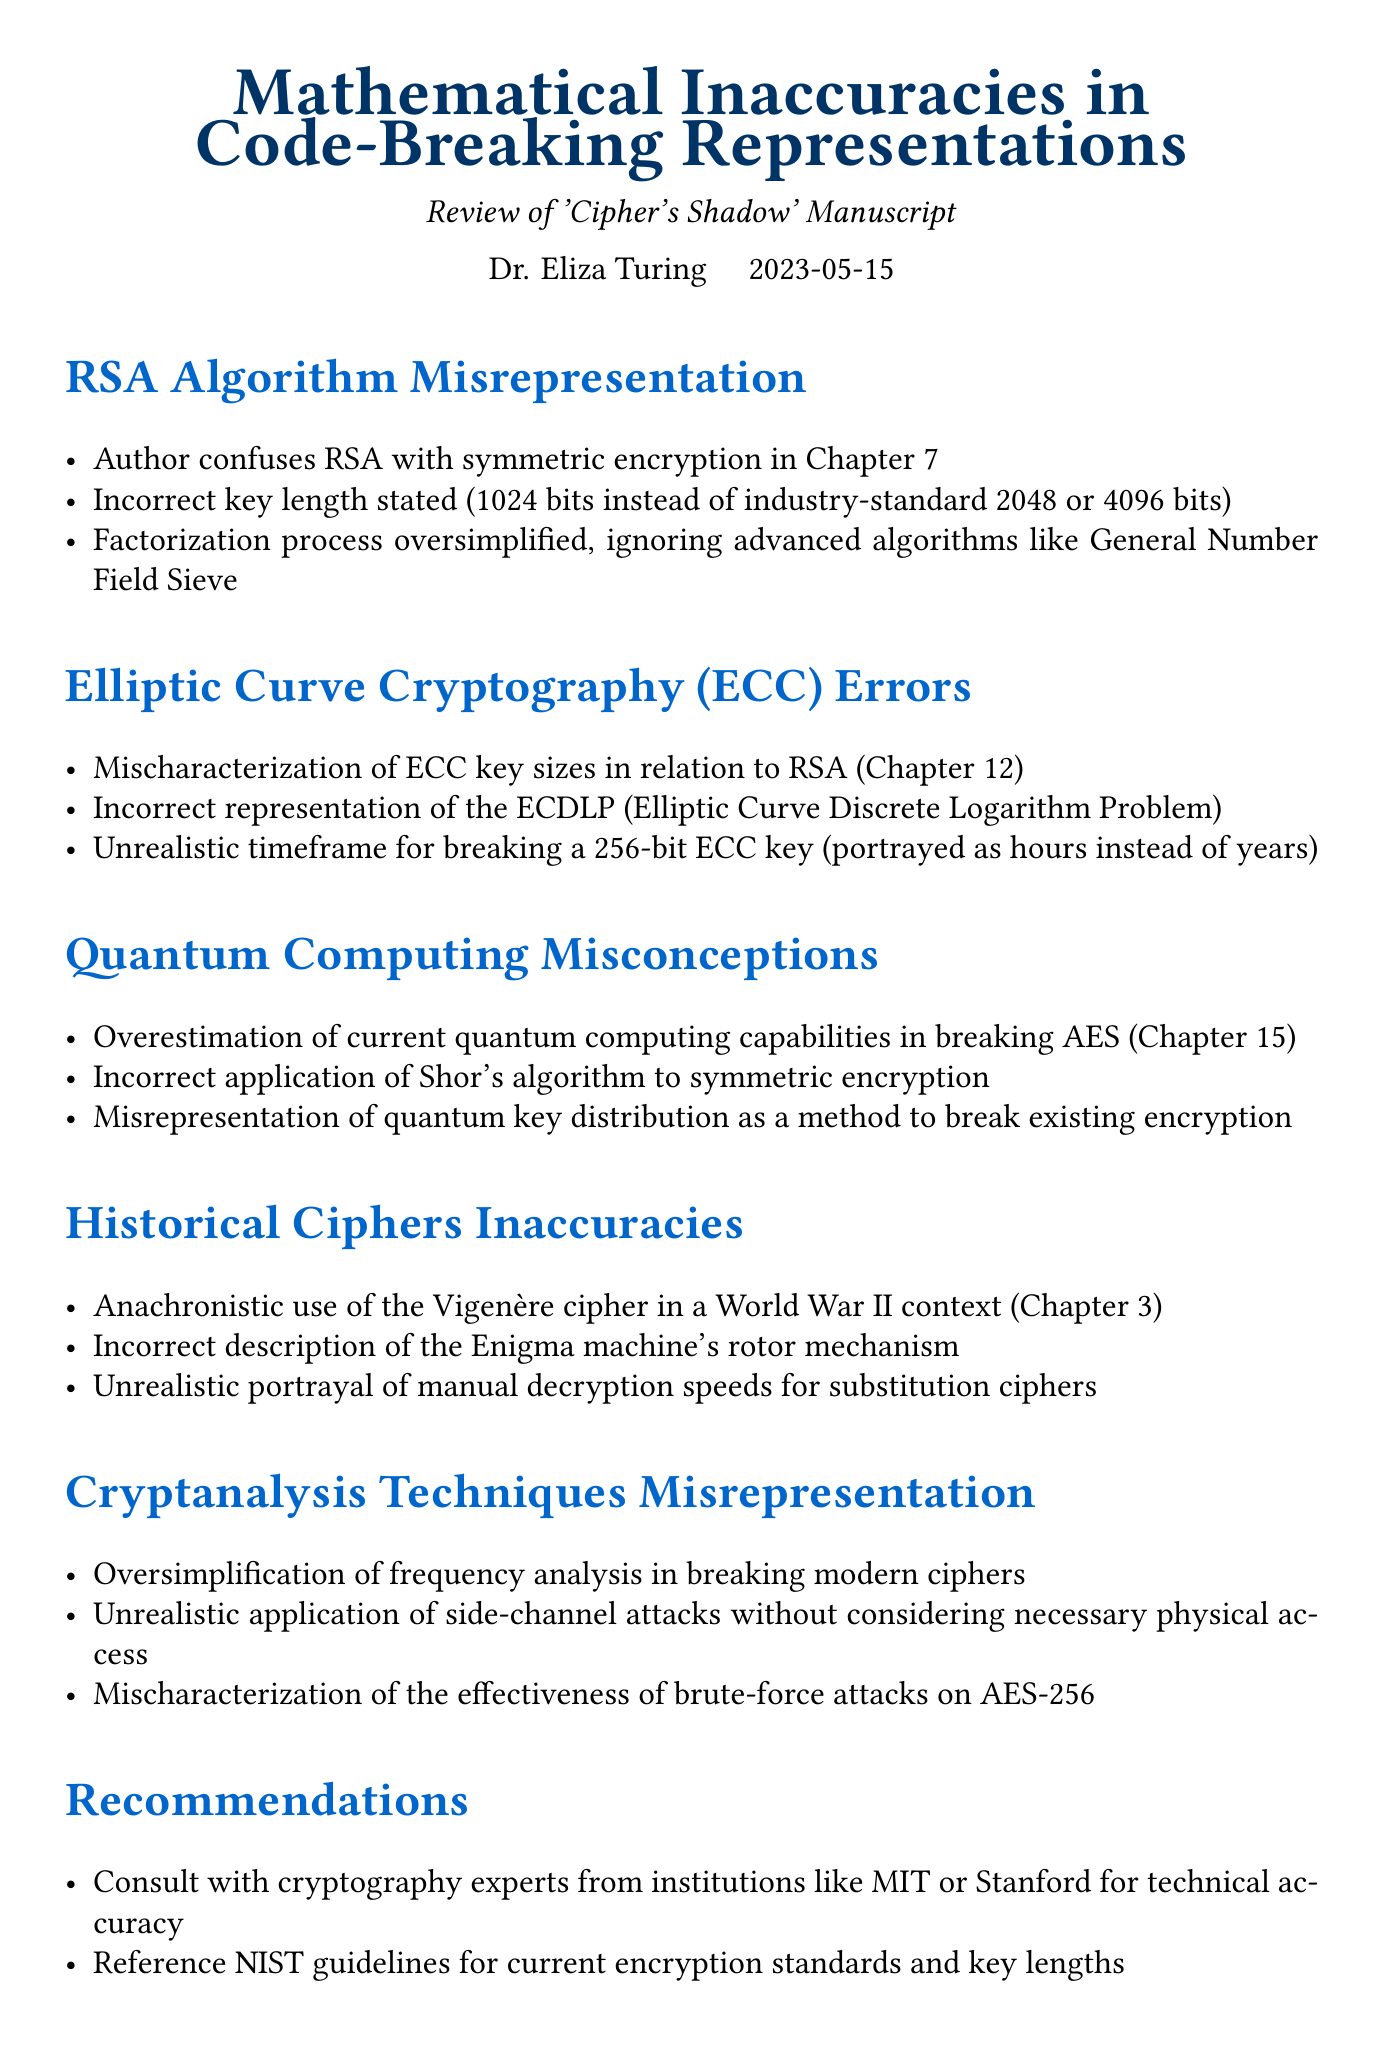What is the title of the memo? The title of the memo is stated at the beginning as "Mathematical Inaccuracies in Code-Breaking Representations: Review of 'Cipher's Shadow' Manuscript".
Answer: Mathematical Inaccuracies in Code-Breaking Representations: Review of 'Cipher's Shadow' Manuscript Who is the author of the memo? The memo mentions the author's name, Dr. Eliza Turing, in the header section.
Answer: Dr. Eliza Turing When was the memo written? The date of the memo is included in the heading, indicating when it was created.
Answer: 2023-05-15 What chapter contains the misrepresentation of RSA? The document explicitly states the misrepresentation of RSA occurs in Chapter 7.
Answer: Chapter 7 What incorrect key length is mentioned for RSA? The document specifies the incorrect key length for RSA encryption stated by the author.
Answer: 1024 bits In which chapter are ECC errors discussed? The ECC errors are specifically mentioned in Chapter 12 of the memo.
Answer: Chapter 12 Which cipher is incorrectly used in a World War II context? The memo discusses an anachronistic use related to a specific cipher within the historical ciphers inaccuracies section.
Answer: Vigenère cipher What is the recommendation regarding cryptography experts? The memo suggests consulting with experts from prestigious institutions for accuracy.
Answer: Consult with cryptography experts from institutions like MIT or Stanford What is the main conclusion regarding 'Cipher's Shadow'? The conclusion summarizes the overall need for revisions to improve the manuscript.
Answer: Significant revisions are needed to ensure mathematical and cryptographic accuracy 